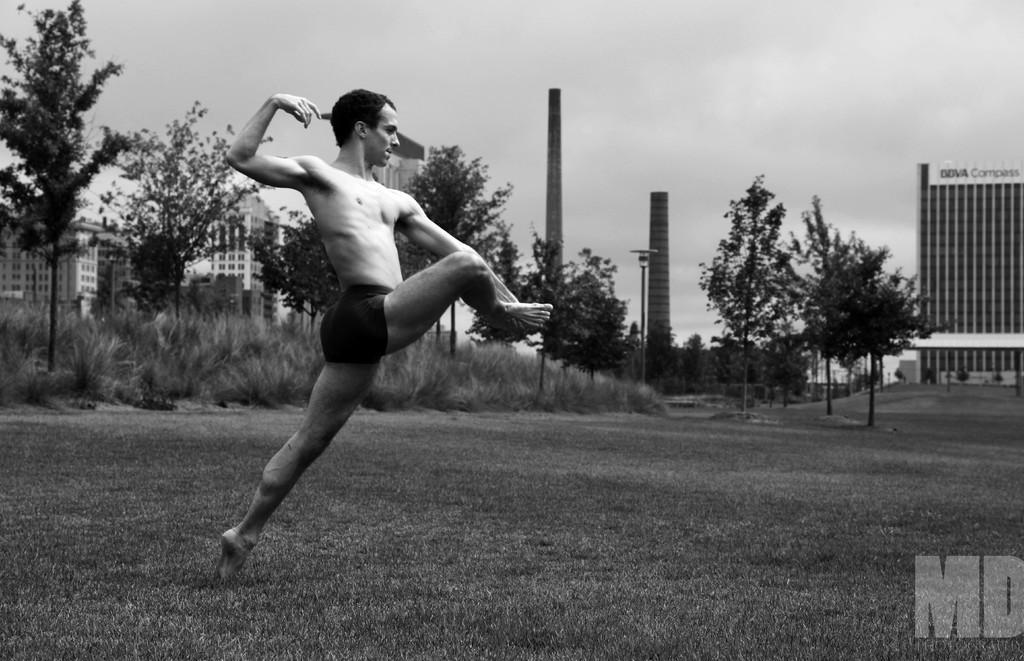In one or two sentences, can you explain what this image depicts? Here in this picture we can see a person performing something on the ground, which is fully covered with grass over there and we can see plants and trees present over there and we can also see buildings, poles, light post and towers present over there and we can see clouds in the sky over there. 